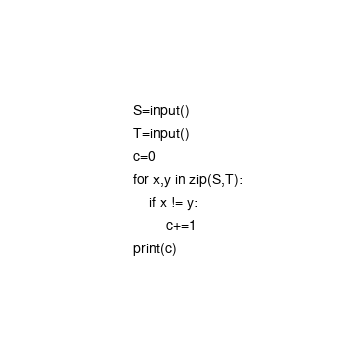Convert code to text. <code><loc_0><loc_0><loc_500><loc_500><_Python_>S=input()
T=input()
c=0
for x,y in zip(S,T):
    if x != y:
        c+=1
print(c)</code> 